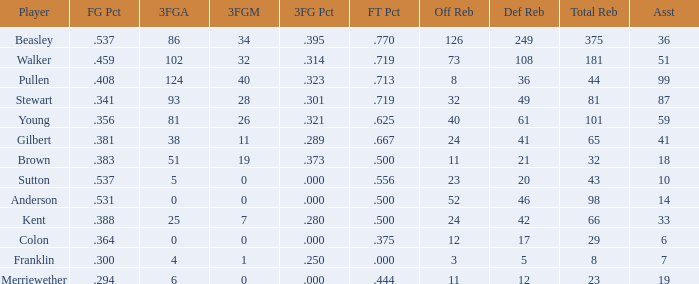What is the sum of offensive rebounds for players who have less than 65 total rebounds, 5 defensive rebounds, and fewer than 7 assists? 0.0. 